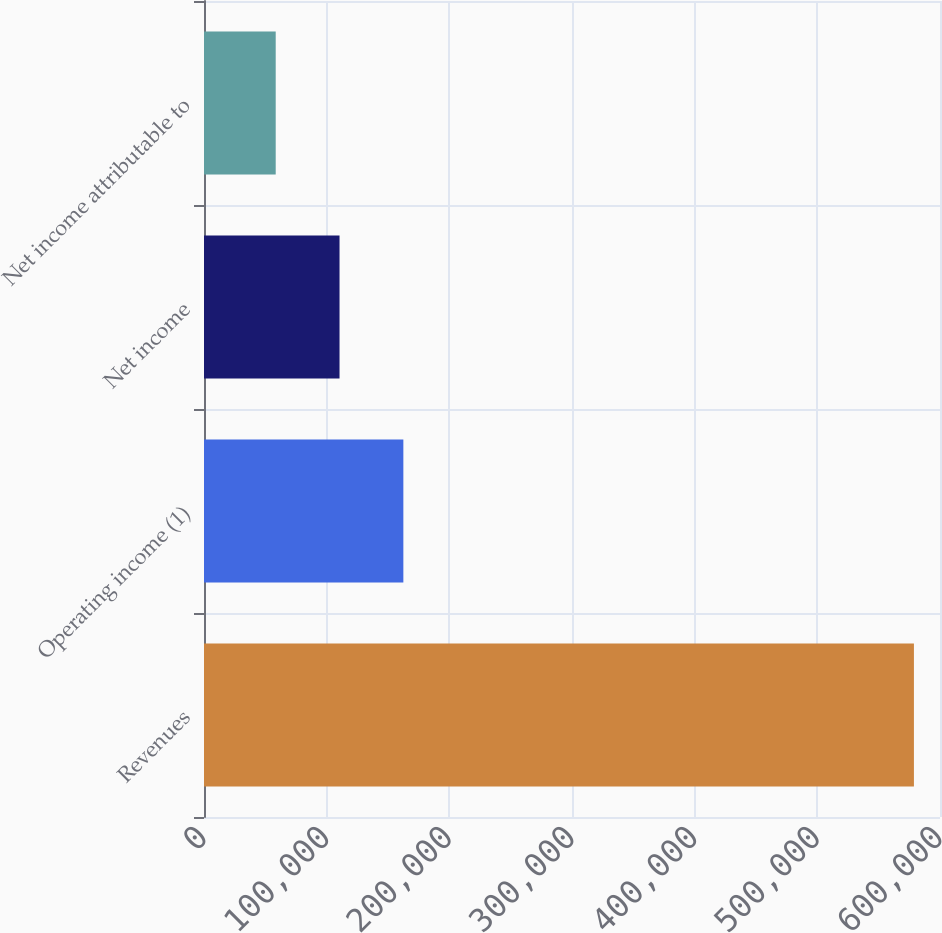<chart> <loc_0><loc_0><loc_500><loc_500><bar_chart><fcel>Revenues<fcel>Operating income (1)<fcel>Net income<fcel>Net income attributable to<nl><fcel>578746<fcel>162519<fcel>110490<fcel>58462<nl></chart> 